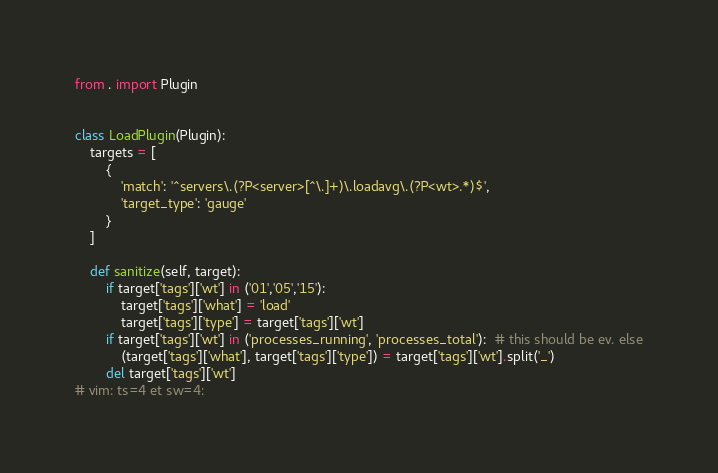Convert code to text. <code><loc_0><loc_0><loc_500><loc_500><_Python_>from . import Plugin


class LoadPlugin(Plugin):
    targets = [
        {
            'match': '^servers\.(?P<server>[^\.]+)\.loadavg\.(?P<wt>.*)$',
            'target_type': 'gauge'
        }
    ]

    def sanitize(self, target):
        if target['tags']['wt'] in ('01','05','15'):
            target['tags']['what'] = 'load'
            target['tags']['type'] = target['tags']['wt']
        if target['tags']['wt'] in ('processes_running', 'processes_total'):  # this should be ev. else
            (target['tags']['what'], target['tags']['type']) = target['tags']['wt'].split('_')
        del target['tags']['wt']
# vim: ts=4 et sw=4:
</code> 